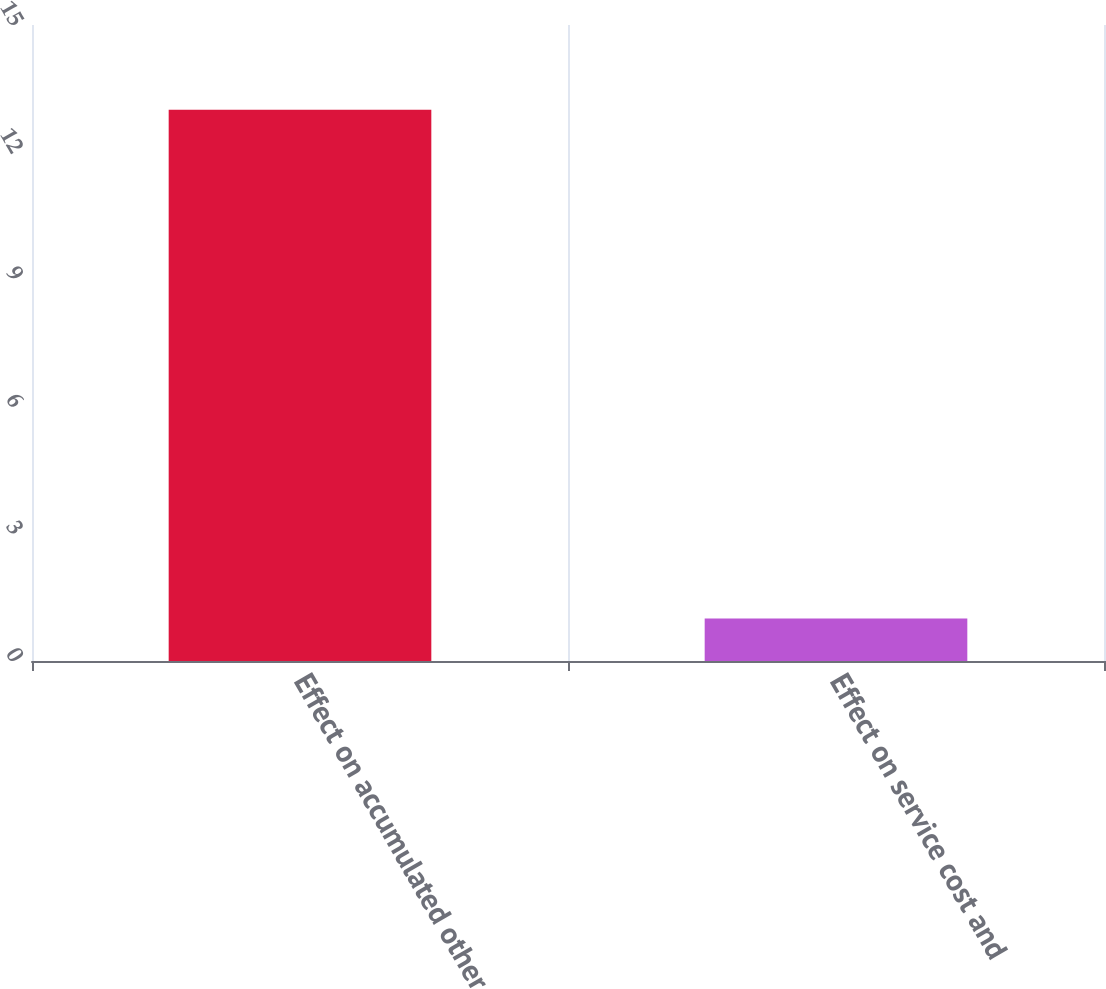Convert chart. <chart><loc_0><loc_0><loc_500><loc_500><bar_chart><fcel>Effect on accumulated other<fcel>Effect on service cost and<nl><fcel>13<fcel>1<nl></chart> 